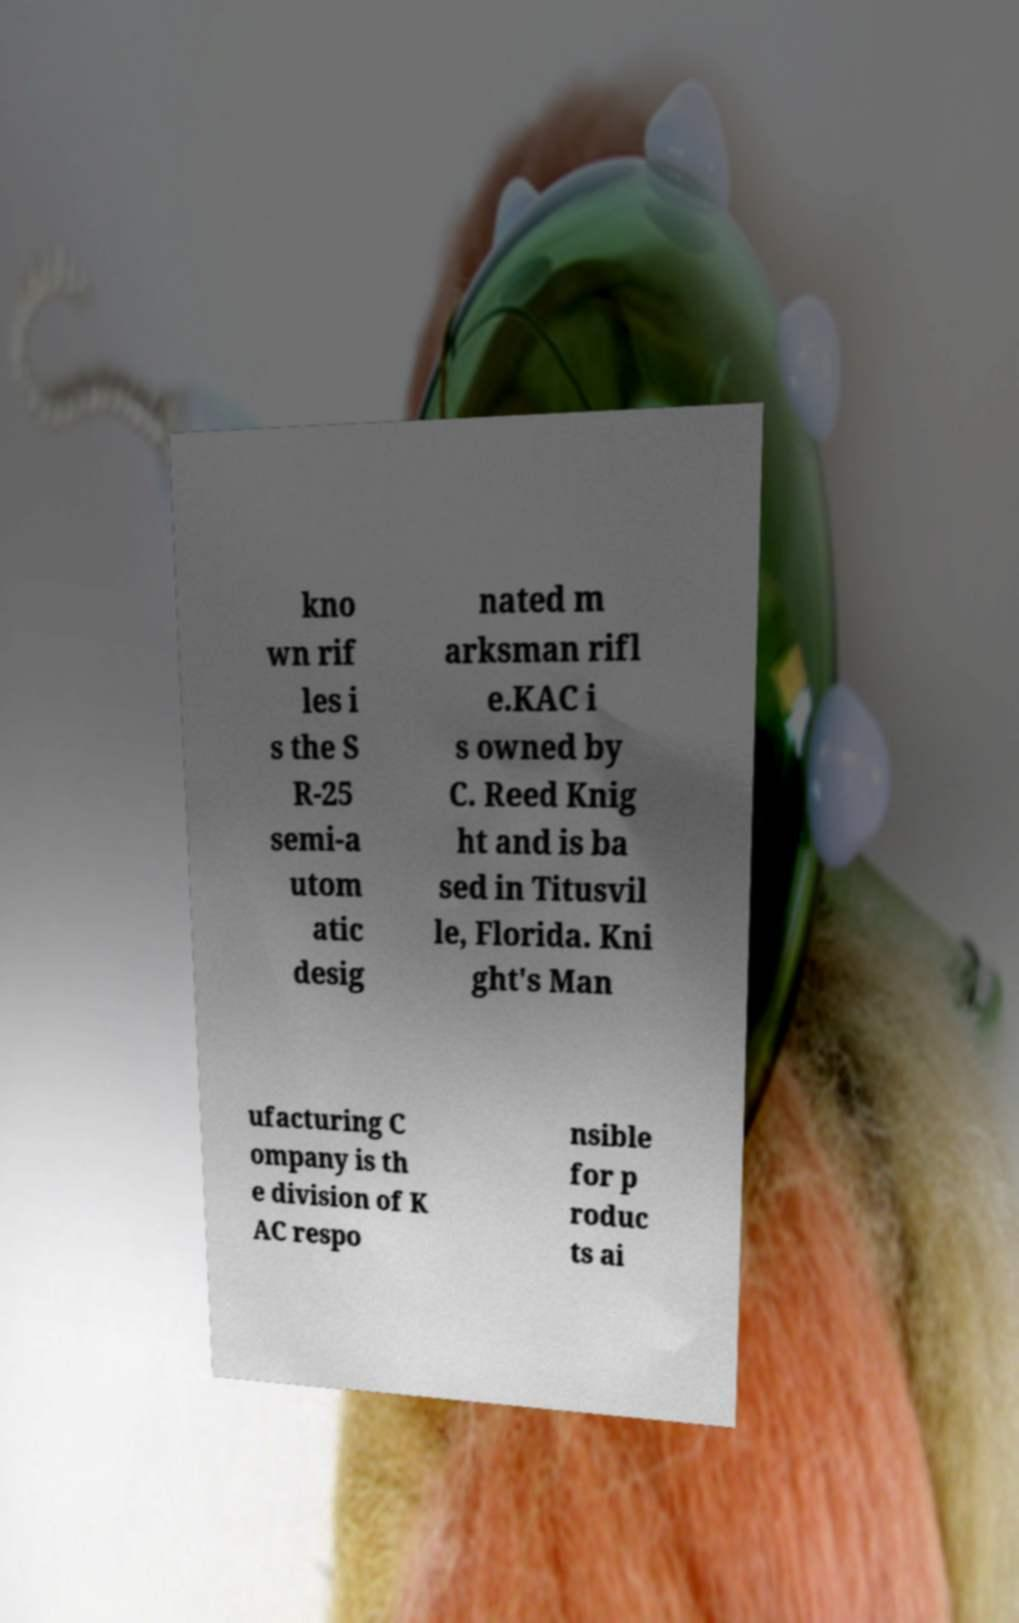Could you assist in decoding the text presented in this image and type it out clearly? kno wn rif les i s the S R-25 semi-a utom atic desig nated m arksman rifl e.KAC i s owned by C. Reed Knig ht and is ba sed in Titusvil le, Florida. Kni ght's Man ufacturing C ompany is th e division of K AC respo nsible for p roduc ts ai 